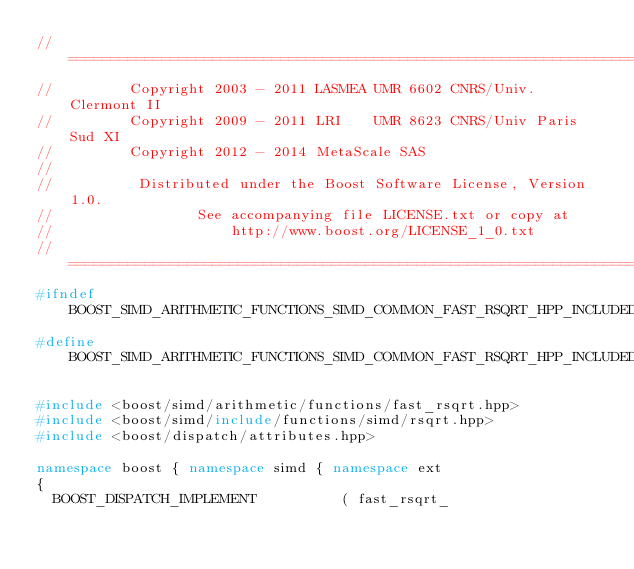Convert code to text. <code><loc_0><loc_0><loc_500><loc_500><_C++_>//==============================================================================
//         Copyright 2003 - 2011 LASMEA UMR 6602 CNRS/Univ. Clermont II
//         Copyright 2009 - 2011 LRI    UMR 8623 CNRS/Univ Paris Sud XI
//         Copyright 2012 - 2014 MetaScale SAS
//
//          Distributed under the Boost Software License, Version 1.0.
//                 See accompanying file LICENSE.txt or copy at
//                     http://www.boost.org/LICENSE_1_0.txt
//==============================================================================
#ifndef BOOST_SIMD_ARITHMETIC_FUNCTIONS_SIMD_COMMON_FAST_RSQRT_HPP_INCLUDED
#define BOOST_SIMD_ARITHMETIC_FUNCTIONS_SIMD_COMMON_FAST_RSQRT_HPP_INCLUDED

#include <boost/simd/arithmetic/functions/fast_rsqrt.hpp>
#include <boost/simd/include/functions/simd/rsqrt.hpp>
#include <boost/dispatch/attributes.hpp>

namespace boost { namespace simd { namespace ext
{
  BOOST_DISPATCH_IMPLEMENT          ( fast_rsqrt_</code> 